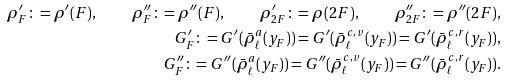<formula> <loc_0><loc_0><loc_500><loc_500>\rho ^ { \prime } _ { F } \colon = \rho ^ { \prime } ( F ) , \quad \rho ^ { \prime \prime } _ { F } \colon = \rho ^ { \prime \prime } ( F ) , \quad \rho ^ { \prime } _ { 2 F } \colon = \rho ( 2 F ) , \quad \rho ^ { \prime \prime } _ { 2 F } \colon = \rho ^ { \prime \prime } ( 2 F ) , \\ G ^ { \prime } _ { F } \colon = G ^ { \prime } ( \bar { \rho } ^ { a } _ { \ell } ( y _ { F } ) ) = G ^ { \prime } ( \bar { \rho } ^ { c , v } _ { \ell } ( y _ { F } ) ) = G ^ { \prime } ( \bar { \rho } ^ { c , r } _ { \ell } ( y _ { F } ) ) , \\ G ^ { \prime \prime } _ { F } \colon = G ^ { \prime \prime } ( \bar { \rho } ^ { a } _ { \ell } ( y _ { F } ) ) = G ^ { \prime \prime } ( \bar { \rho } ^ { c , v } _ { \ell } ( y _ { F } ) ) = G ^ { \prime \prime } ( \bar { \rho } ^ { c , r } _ { \ell } ( y _ { F } ) ) .</formula> 